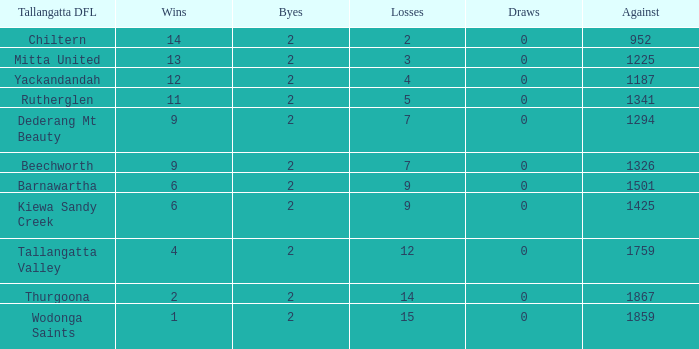What are the draws when victories are less than 9 and byes less than 2? 0.0. 